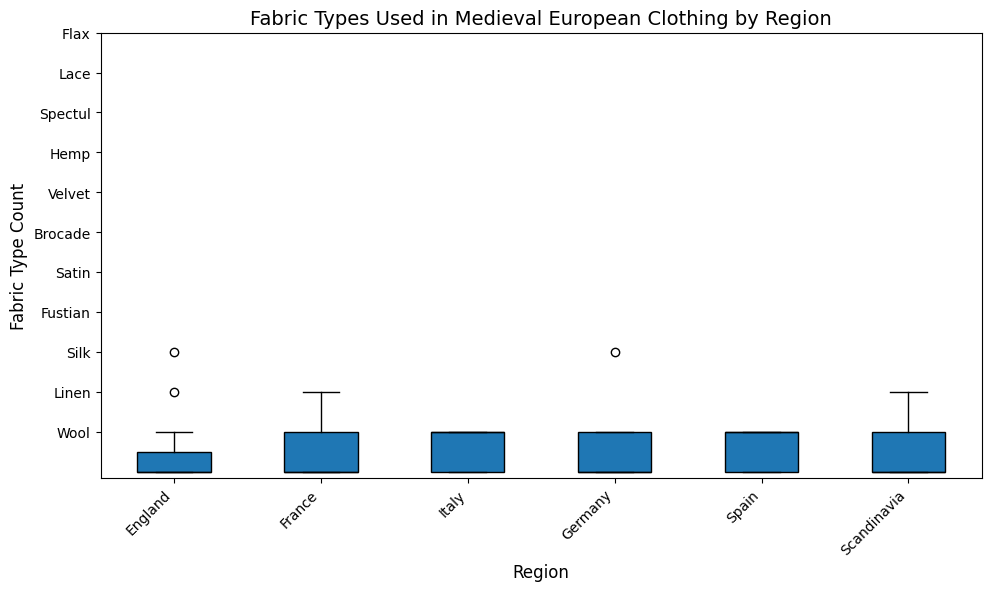Which region has the widest range of fabric type counts? To determine the widest range, look at the vertical spread of the boxplot whiskers for each region. The region with the widest vertical spread indicates the largest range of fabric type counts.
Answer: Germany Which region has the highest median count of any fabric type? Examine the horizontal line within each box, which represents the median. The region with the highest median line has the highest median count of a fabric type.
Answer: England Which fabric type shows the most variation across all regions? To find the fabric type with the most variation, observe which row shows the widest range of counts within the boxplots. The fabric type with the largest height difference indicates the highest variation.
Answer: Wool How does the median fabric type count for England compare to that of Germany? Look at the median lines within the boxplots for England and Germany and compare their positions on the y-axis.
Answer: England's median is higher than Germany's Which regions have the same median fabric type count? Compare the positions of the median lines across all regions to identify those that align at the same height.
Answer: Scandinavia and France Are there any regions with outliers in their fabric type counts? Check for any points that fall outside the whiskers in the boxplots. These points represent outliers.
Answer: Yes, Italy What is the most common fabric type in England? Look for the highest point within the boxplot for England, as this indicates the fabric type with the highest count.
Answer: Wool How does the distribution of fabric types in France compare with that of Spain? Compare the boxplots for France and Spain, noting the range, median, and spread of fabric types for both regions.
Answer: France has a more varied distribution with higher counts around Silk and Wool, while Spain has outliers in Spectul and Lace What is the median fabric type count for all regions combined? Average the median lines observed in each region's boxplot to estimate the overall median fabric type count.
Answer: Around 2 (based on visual estimation) Which region has the least variation in fabric type counts? Identify the region with the smallest vertical spread in its boxplot whiskers. This indicates the least variation.
Answer: Spain 